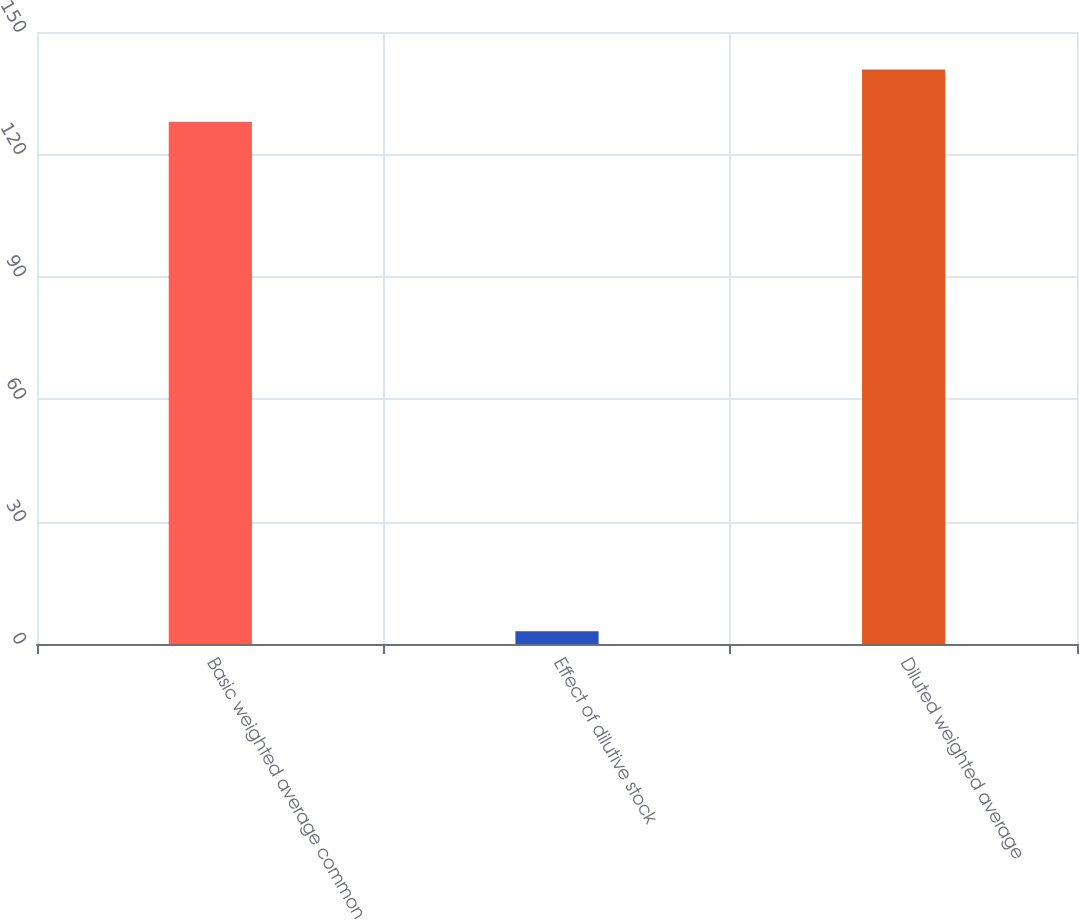<chart> <loc_0><loc_0><loc_500><loc_500><bar_chart><fcel>Basic weighted average common<fcel>Effect of dilutive stock<fcel>Diluted weighted average<nl><fcel>128<fcel>3.1<fcel>140.8<nl></chart> 